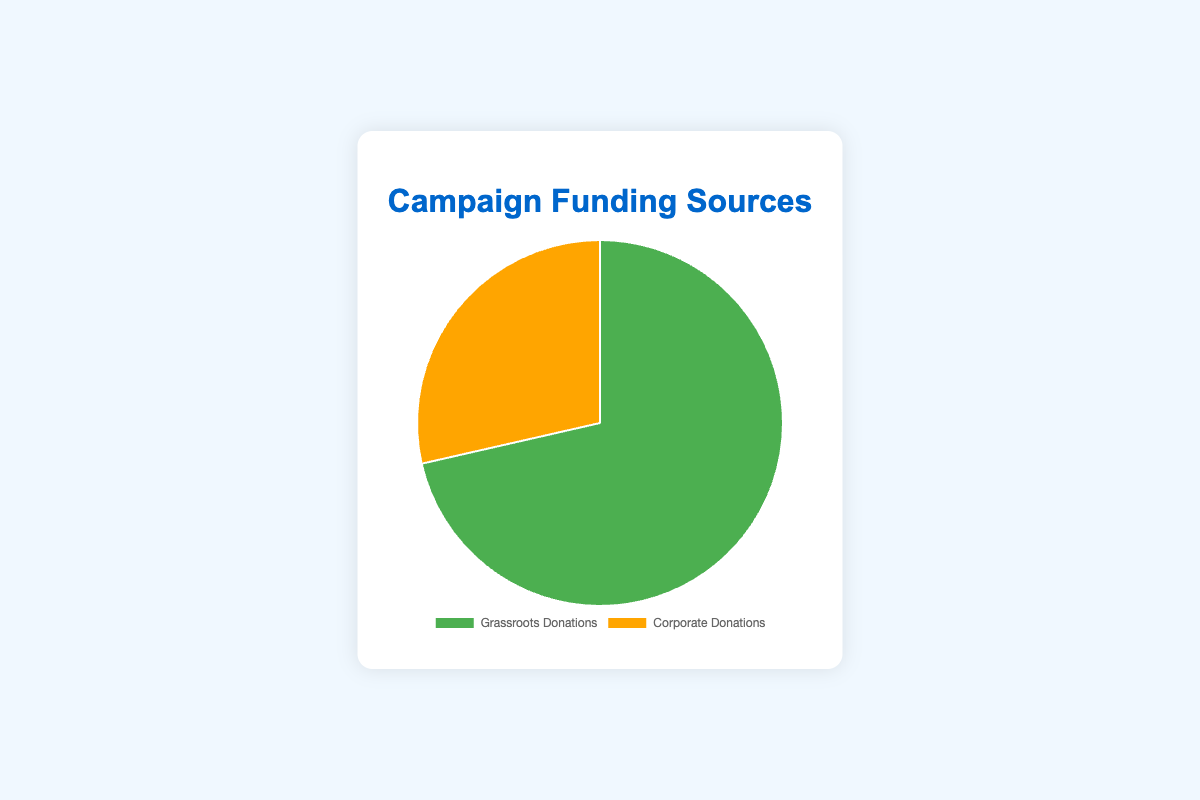What percentage of the total funding comes from grassroots donations? The total funding is the sum of grassroots and corporate donations: $2,000,000 + $800,000 = $2,800,000. The percentage from grassroots donations is ($2,000,000 / $2,800,000) * 100%.
Answer: 71.43% Which type of donation contributes more to the campaign funding? Comparing the amounts: $2,000,000 (grassroots) and $800,000 (corporate). Grassroots donations are higher.
Answer: Grassroots Donations What is the difference in amount between grassroots and corporate donations? The difference is calculated by subtracting the corporate donations from grassroots donations: $2,000,000 - $800,000.
Answer: $1,200,000 What is the total amount of funding raised by the campaign? The total amount is the sum of grassroots and corporate donations: $2,000,000 + $800,000.
Answer: $2,800,000 If the campaign wanted to double its corporate donations, how much more would it need to raise? To double the corporate donations, the campaign needs an additional $800,000 because $800,000 * 2 = $1,600,000, and it already has $800,000.
Answer: $800,000 What is the combined percentage contribution of 'Health Care Companies' and 'Financial Services Firms' if each represents an equal part of corporate donations? Each corporate donor type is assumed to represent an equal share. Thus, each contributes 1/4 of the corporate donations. Combined, 'Healthcare Companies' and 'Financial Services Firms' contribute (1/4 + 1/4) * 100% = 50% of $800,000. This is $400,000, which is 14.29% of the total funding.
Answer: 14.29% If the campaign receives an additional $1,000,000 in grassroots donations, what percentage of the total funding would then come from grassroots donations? After receiving additional $1,000,000, grassroots donations become $3,000,000 and total funding becomes $3,800,000. The new percentage is ($3,000,000 / $3,800,000) * 100%.
Answer: 78.95% Between grassroots and corporate donations, which has a greater financial support from entities and why? Grassroots donations come from four types of entities, while corporate donations also come from four types of entities. However, this question can't be fully determined visually as it requires additional data on funding amounts from each entity.
Answer: Undeterminable by figure alone Which type of donation would you consider having more diverse support based on the entities listed and why? Grassroots donations include 'Individual Donors', 'Small Online Contributions', 'Local Fundraisers', and 'Community Events', which indicate varied grassroots-level support. Corporate donations are from specific sectors.
Answer: Grassroots Donations If the campaign aims to have $3,000,000 funding in total while keeping the current distribution percentages, how much funding should come from grassroots and corporate donations respectively? Keeping the ratio the same (71.43% grassroots, 28.57% corporate):
Grassroots: 71.43% of $3,000,000 = $2,142,900.
Corporate: 28.57% of $3,000,000 = $857,100.
Answer: $2,142,900 from grassroots; $857,100 from corporate 